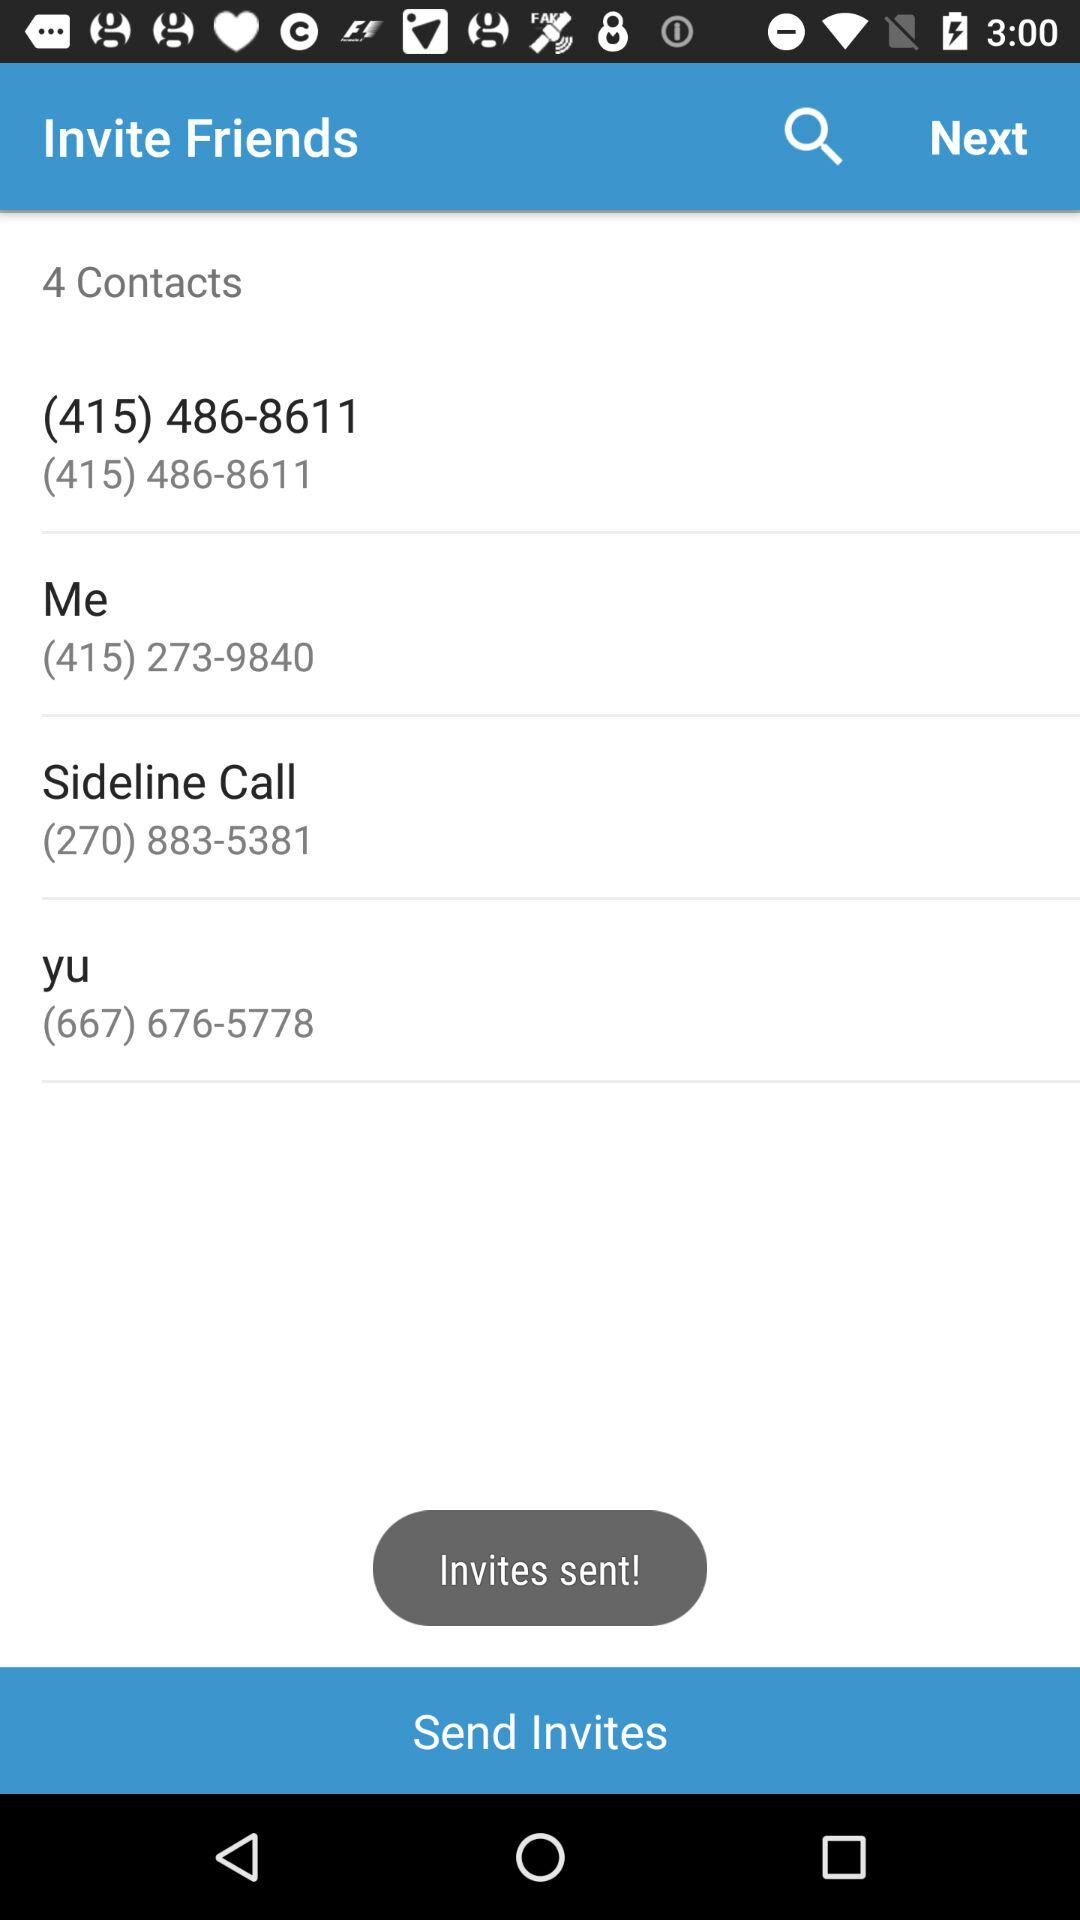To whom invites have been sent? Invites have been sent to (415) 486-8611, Me, Sideline Call and Yu. 